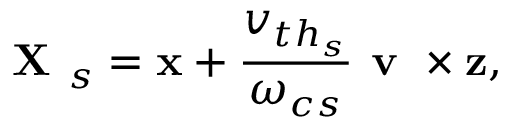Convert formula to latex. <formula><loc_0><loc_0><loc_500><loc_500>X _ { s } = x + \frac { v _ { { t h } _ { s } } } { \omega _ { c s } } v \times z ,</formula> 